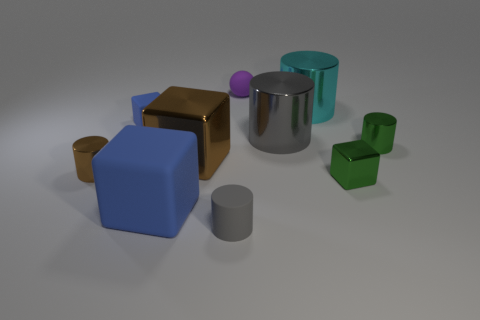Subtract all rubber cylinders. How many cylinders are left? 4 Subtract all blocks. How many objects are left? 6 Add 6 big gray things. How many big gray things are left? 7 Add 8 tiny green objects. How many tiny green objects exist? 10 Subtract all brown cylinders. How many cylinders are left? 4 Subtract 0 cyan balls. How many objects are left? 10 Subtract 1 balls. How many balls are left? 0 Subtract all green cylinders. Subtract all brown cubes. How many cylinders are left? 4 Subtract all gray balls. How many red blocks are left? 0 Subtract all gray metallic cylinders. Subtract all tiny blue things. How many objects are left? 8 